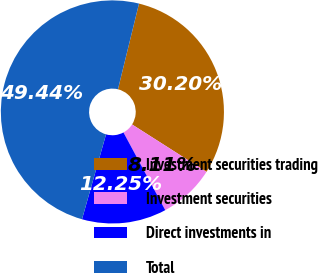Convert chart. <chart><loc_0><loc_0><loc_500><loc_500><pie_chart><fcel>Investment securities trading<fcel>Investment securities<fcel>Direct investments in<fcel>Total<nl><fcel>30.2%<fcel>8.11%<fcel>12.25%<fcel>49.44%<nl></chart> 